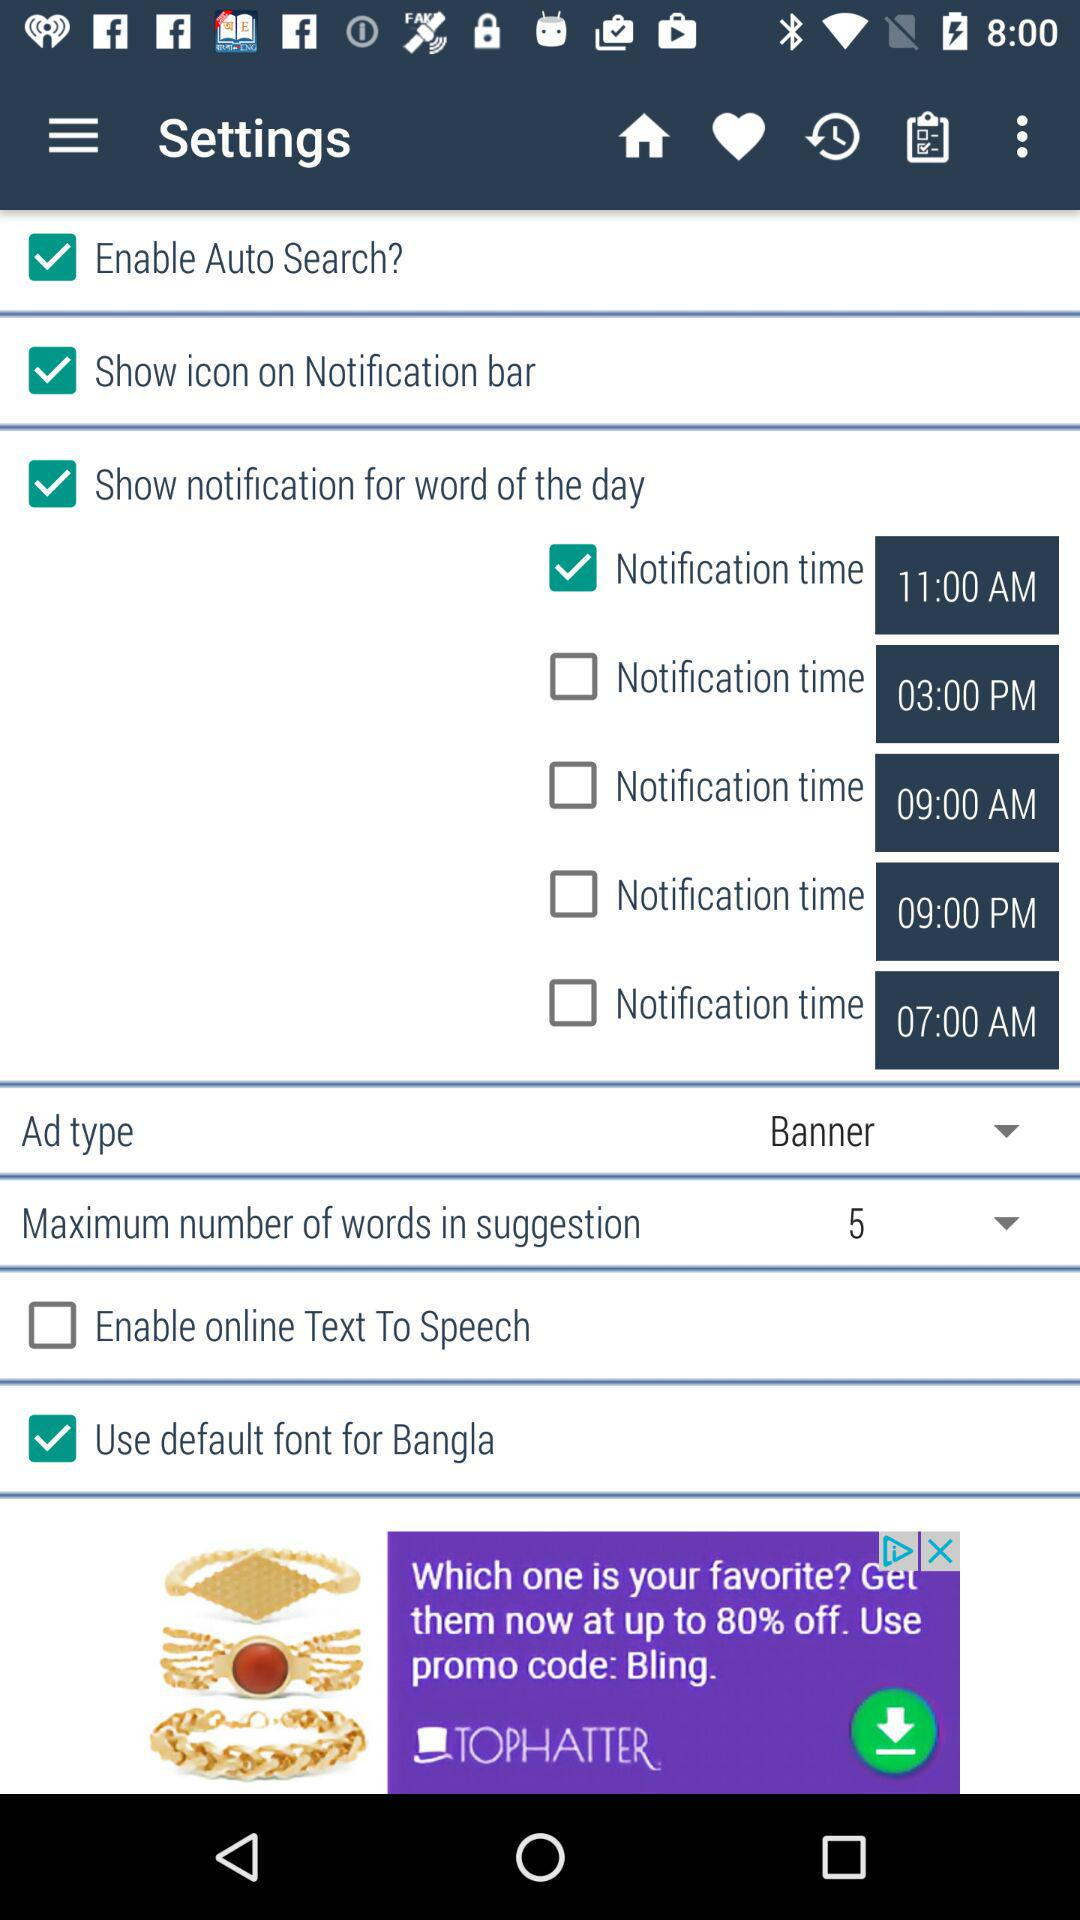How many time options does the notification feature have?
Answer the question using a single word or phrase. 5 